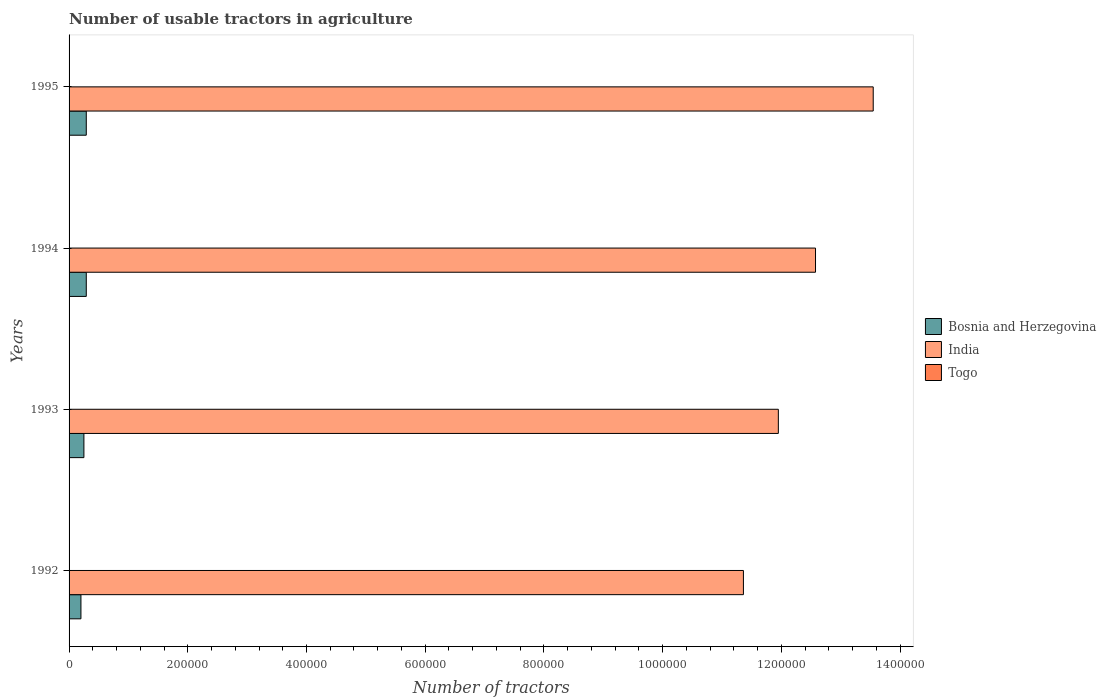How many different coloured bars are there?
Offer a very short reply. 3. How many groups of bars are there?
Provide a succinct answer. 4. Are the number of bars per tick equal to the number of legend labels?
Give a very brief answer. Yes. Are the number of bars on each tick of the Y-axis equal?
Your answer should be very brief. Yes. How many bars are there on the 4th tick from the bottom?
Keep it short and to the point. 3. What is the label of the 1st group of bars from the top?
Provide a short and direct response. 1995. What is the number of usable tractors in agriculture in Bosnia and Herzegovina in 1995?
Your answer should be compact. 2.90e+04. Across all years, what is the maximum number of usable tractors in agriculture in India?
Make the answer very short. 1.35e+06. Across all years, what is the minimum number of usable tractors in agriculture in Togo?
Your response must be concise. 85. In which year was the number of usable tractors in agriculture in Togo minimum?
Provide a short and direct response. 1995. What is the total number of usable tractors in agriculture in Togo in the graph?
Keep it short and to the point. 358. What is the difference between the number of usable tractors in agriculture in India in 1992 and that in 1994?
Your answer should be very brief. -1.21e+05. What is the difference between the number of usable tractors in agriculture in India in 1994 and the number of usable tractors in agriculture in Bosnia and Herzegovina in 1995?
Offer a very short reply. 1.23e+06. What is the average number of usable tractors in agriculture in Togo per year?
Provide a short and direct response. 89.5. In the year 1994, what is the difference between the number of usable tractors in agriculture in India and number of usable tractors in agriculture in Bosnia and Herzegovina?
Provide a short and direct response. 1.23e+06. What is the ratio of the number of usable tractors in agriculture in Togo in 1992 to that in 1993?
Ensure brevity in your answer.  1.06. Is the difference between the number of usable tractors in agriculture in India in 1992 and 1994 greater than the difference between the number of usable tractors in agriculture in Bosnia and Herzegovina in 1992 and 1994?
Your response must be concise. No. What is the difference between the highest and the second highest number of usable tractors in agriculture in Togo?
Offer a very short reply. 5. In how many years, is the number of usable tractors in agriculture in India greater than the average number of usable tractors in agriculture in India taken over all years?
Provide a succinct answer. 2. Is the sum of the number of usable tractors in agriculture in India in 1994 and 1995 greater than the maximum number of usable tractors in agriculture in Bosnia and Herzegovina across all years?
Offer a terse response. Yes. What does the 3rd bar from the top in 1993 represents?
Your answer should be very brief. Bosnia and Herzegovina. What does the 3rd bar from the bottom in 1995 represents?
Your answer should be very brief. Togo. Is it the case that in every year, the sum of the number of usable tractors in agriculture in India and number of usable tractors in agriculture in Bosnia and Herzegovina is greater than the number of usable tractors in agriculture in Togo?
Offer a very short reply. Yes. How many years are there in the graph?
Provide a short and direct response. 4. What is the difference between two consecutive major ticks on the X-axis?
Provide a succinct answer. 2.00e+05. Does the graph contain any zero values?
Offer a terse response. No. Does the graph contain grids?
Provide a short and direct response. No. How many legend labels are there?
Keep it short and to the point. 3. How are the legend labels stacked?
Your response must be concise. Vertical. What is the title of the graph?
Your answer should be very brief. Number of usable tractors in agriculture. Does "Tuvalu" appear as one of the legend labels in the graph?
Your response must be concise. No. What is the label or title of the X-axis?
Offer a very short reply. Number of tractors. What is the Number of tractors in India in 1992?
Give a very brief answer. 1.14e+06. What is the Number of tractors in Togo in 1992?
Offer a terse response. 95. What is the Number of tractors in Bosnia and Herzegovina in 1993?
Keep it short and to the point. 2.50e+04. What is the Number of tractors in India in 1993?
Your answer should be compact. 1.20e+06. What is the Number of tractors in Bosnia and Herzegovina in 1994?
Offer a very short reply. 2.90e+04. What is the Number of tractors in India in 1994?
Ensure brevity in your answer.  1.26e+06. What is the Number of tractors of Togo in 1994?
Ensure brevity in your answer.  88. What is the Number of tractors in Bosnia and Herzegovina in 1995?
Ensure brevity in your answer.  2.90e+04. What is the Number of tractors of India in 1995?
Ensure brevity in your answer.  1.35e+06. What is the Number of tractors in Togo in 1995?
Provide a succinct answer. 85. Across all years, what is the maximum Number of tractors in Bosnia and Herzegovina?
Your response must be concise. 2.90e+04. Across all years, what is the maximum Number of tractors in India?
Your answer should be very brief. 1.35e+06. Across all years, what is the minimum Number of tractors in India?
Keep it short and to the point. 1.14e+06. What is the total Number of tractors of Bosnia and Herzegovina in the graph?
Provide a short and direct response. 1.03e+05. What is the total Number of tractors of India in the graph?
Provide a succinct answer. 4.94e+06. What is the total Number of tractors in Togo in the graph?
Keep it short and to the point. 358. What is the difference between the Number of tractors in Bosnia and Herzegovina in 1992 and that in 1993?
Give a very brief answer. -5000. What is the difference between the Number of tractors of India in 1992 and that in 1993?
Ensure brevity in your answer.  -5.89e+04. What is the difference between the Number of tractors in Bosnia and Herzegovina in 1992 and that in 1994?
Your response must be concise. -9000. What is the difference between the Number of tractors in India in 1992 and that in 1994?
Make the answer very short. -1.21e+05. What is the difference between the Number of tractors in Bosnia and Herzegovina in 1992 and that in 1995?
Ensure brevity in your answer.  -9000. What is the difference between the Number of tractors in India in 1992 and that in 1995?
Give a very brief answer. -2.19e+05. What is the difference between the Number of tractors of Togo in 1992 and that in 1995?
Offer a terse response. 10. What is the difference between the Number of tractors in Bosnia and Herzegovina in 1993 and that in 1994?
Provide a short and direct response. -4000. What is the difference between the Number of tractors of India in 1993 and that in 1994?
Your response must be concise. -6.26e+04. What is the difference between the Number of tractors in Bosnia and Herzegovina in 1993 and that in 1995?
Ensure brevity in your answer.  -4000. What is the difference between the Number of tractors in India in 1993 and that in 1995?
Your answer should be compact. -1.60e+05. What is the difference between the Number of tractors in Bosnia and Herzegovina in 1994 and that in 1995?
Provide a succinct answer. 0. What is the difference between the Number of tractors in India in 1994 and that in 1995?
Your answer should be compact. -9.72e+04. What is the difference between the Number of tractors in Bosnia and Herzegovina in 1992 and the Number of tractors in India in 1993?
Offer a terse response. -1.18e+06. What is the difference between the Number of tractors of Bosnia and Herzegovina in 1992 and the Number of tractors of Togo in 1993?
Offer a terse response. 1.99e+04. What is the difference between the Number of tractors in India in 1992 and the Number of tractors in Togo in 1993?
Offer a very short reply. 1.14e+06. What is the difference between the Number of tractors in Bosnia and Herzegovina in 1992 and the Number of tractors in India in 1994?
Your answer should be very brief. -1.24e+06. What is the difference between the Number of tractors in Bosnia and Herzegovina in 1992 and the Number of tractors in Togo in 1994?
Provide a succinct answer. 1.99e+04. What is the difference between the Number of tractors of India in 1992 and the Number of tractors of Togo in 1994?
Offer a terse response. 1.14e+06. What is the difference between the Number of tractors of Bosnia and Herzegovina in 1992 and the Number of tractors of India in 1995?
Keep it short and to the point. -1.33e+06. What is the difference between the Number of tractors of Bosnia and Herzegovina in 1992 and the Number of tractors of Togo in 1995?
Your answer should be compact. 1.99e+04. What is the difference between the Number of tractors of India in 1992 and the Number of tractors of Togo in 1995?
Provide a succinct answer. 1.14e+06. What is the difference between the Number of tractors in Bosnia and Herzegovina in 1993 and the Number of tractors in India in 1994?
Offer a very short reply. -1.23e+06. What is the difference between the Number of tractors of Bosnia and Herzegovina in 1993 and the Number of tractors of Togo in 1994?
Offer a very short reply. 2.49e+04. What is the difference between the Number of tractors of India in 1993 and the Number of tractors of Togo in 1994?
Provide a short and direct response. 1.19e+06. What is the difference between the Number of tractors in Bosnia and Herzegovina in 1993 and the Number of tractors in India in 1995?
Your response must be concise. -1.33e+06. What is the difference between the Number of tractors in Bosnia and Herzegovina in 1993 and the Number of tractors in Togo in 1995?
Ensure brevity in your answer.  2.49e+04. What is the difference between the Number of tractors in India in 1993 and the Number of tractors in Togo in 1995?
Your response must be concise. 1.19e+06. What is the difference between the Number of tractors of Bosnia and Herzegovina in 1994 and the Number of tractors of India in 1995?
Give a very brief answer. -1.33e+06. What is the difference between the Number of tractors in Bosnia and Herzegovina in 1994 and the Number of tractors in Togo in 1995?
Your answer should be compact. 2.89e+04. What is the difference between the Number of tractors of India in 1994 and the Number of tractors of Togo in 1995?
Ensure brevity in your answer.  1.26e+06. What is the average Number of tractors in Bosnia and Herzegovina per year?
Your answer should be compact. 2.58e+04. What is the average Number of tractors in India per year?
Keep it short and to the point. 1.24e+06. What is the average Number of tractors of Togo per year?
Give a very brief answer. 89.5. In the year 1992, what is the difference between the Number of tractors of Bosnia and Herzegovina and Number of tractors of India?
Give a very brief answer. -1.12e+06. In the year 1992, what is the difference between the Number of tractors in Bosnia and Herzegovina and Number of tractors in Togo?
Ensure brevity in your answer.  1.99e+04. In the year 1992, what is the difference between the Number of tractors in India and Number of tractors in Togo?
Provide a short and direct response. 1.14e+06. In the year 1993, what is the difference between the Number of tractors in Bosnia and Herzegovina and Number of tractors in India?
Provide a short and direct response. -1.17e+06. In the year 1993, what is the difference between the Number of tractors in Bosnia and Herzegovina and Number of tractors in Togo?
Your response must be concise. 2.49e+04. In the year 1993, what is the difference between the Number of tractors of India and Number of tractors of Togo?
Offer a very short reply. 1.19e+06. In the year 1994, what is the difference between the Number of tractors in Bosnia and Herzegovina and Number of tractors in India?
Provide a succinct answer. -1.23e+06. In the year 1994, what is the difference between the Number of tractors of Bosnia and Herzegovina and Number of tractors of Togo?
Offer a terse response. 2.89e+04. In the year 1994, what is the difference between the Number of tractors in India and Number of tractors in Togo?
Keep it short and to the point. 1.26e+06. In the year 1995, what is the difference between the Number of tractors of Bosnia and Herzegovina and Number of tractors of India?
Offer a terse response. -1.33e+06. In the year 1995, what is the difference between the Number of tractors in Bosnia and Herzegovina and Number of tractors in Togo?
Provide a succinct answer. 2.89e+04. In the year 1995, what is the difference between the Number of tractors in India and Number of tractors in Togo?
Offer a very short reply. 1.35e+06. What is the ratio of the Number of tractors of India in 1992 to that in 1993?
Give a very brief answer. 0.95. What is the ratio of the Number of tractors of Togo in 1992 to that in 1993?
Your answer should be very brief. 1.06. What is the ratio of the Number of tractors in Bosnia and Herzegovina in 1992 to that in 1994?
Your answer should be very brief. 0.69. What is the ratio of the Number of tractors in India in 1992 to that in 1994?
Your answer should be compact. 0.9. What is the ratio of the Number of tractors of Togo in 1992 to that in 1994?
Provide a short and direct response. 1.08. What is the ratio of the Number of tractors in Bosnia and Herzegovina in 1992 to that in 1995?
Provide a succinct answer. 0.69. What is the ratio of the Number of tractors in India in 1992 to that in 1995?
Your response must be concise. 0.84. What is the ratio of the Number of tractors of Togo in 1992 to that in 1995?
Give a very brief answer. 1.12. What is the ratio of the Number of tractors in Bosnia and Herzegovina in 1993 to that in 1994?
Your response must be concise. 0.86. What is the ratio of the Number of tractors of India in 1993 to that in 1994?
Ensure brevity in your answer.  0.95. What is the ratio of the Number of tractors of Togo in 1993 to that in 1994?
Make the answer very short. 1.02. What is the ratio of the Number of tractors of Bosnia and Herzegovina in 1993 to that in 1995?
Provide a succinct answer. 0.86. What is the ratio of the Number of tractors in India in 1993 to that in 1995?
Give a very brief answer. 0.88. What is the ratio of the Number of tractors in Togo in 1993 to that in 1995?
Your answer should be compact. 1.06. What is the ratio of the Number of tractors of India in 1994 to that in 1995?
Your response must be concise. 0.93. What is the ratio of the Number of tractors in Togo in 1994 to that in 1995?
Your answer should be very brief. 1.04. What is the difference between the highest and the second highest Number of tractors of India?
Make the answer very short. 9.72e+04. What is the difference between the highest and the lowest Number of tractors in Bosnia and Herzegovina?
Offer a very short reply. 9000. What is the difference between the highest and the lowest Number of tractors in India?
Your answer should be very brief. 2.19e+05. 